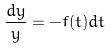Convert formula to latex. <formula><loc_0><loc_0><loc_500><loc_500>\frac { d y } { y } = - f ( t ) d t</formula> 